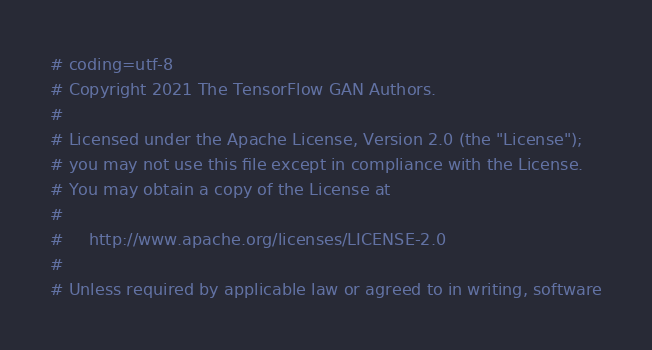<code> <loc_0><loc_0><loc_500><loc_500><_Python_># coding=utf-8
# Copyright 2021 The TensorFlow GAN Authors.
#
# Licensed under the Apache License, Version 2.0 (the "License");
# you may not use this file except in compliance with the License.
# You may obtain a copy of the License at
#
#     http://www.apache.org/licenses/LICENSE-2.0
#
# Unless required by applicable law or agreed to in writing, software</code> 